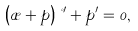Convert formula to latex. <formula><loc_0><loc_0><loc_500><loc_500>\left ( \rho + p \right ) \nu ^ { \prime } + { p ^ { \prime } } = 0 ,</formula> 